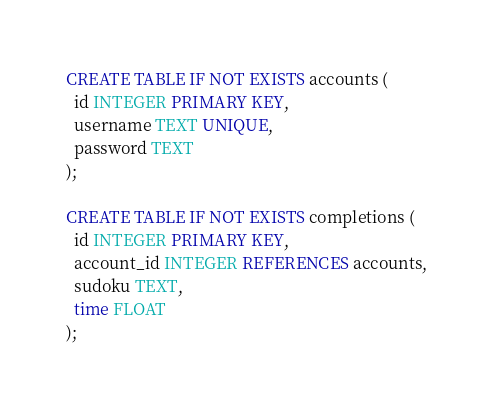<code> <loc_0><loc_0><loc_500><loc_500><_SQL_>CREATE TABLE IF NOT EXISTS accounts (
  id INTEGER PRIMARY KEY,
  username TEXT UNIQUE,
  password TEXT
);

CREATE TABLE IF NOT EXISTS completions (
  id INTEGER PRIMARY KEY,
  account_id INTEGER REFERENCES accounts,
  sudoku TEXT,
  time FLOAT
);</code> 